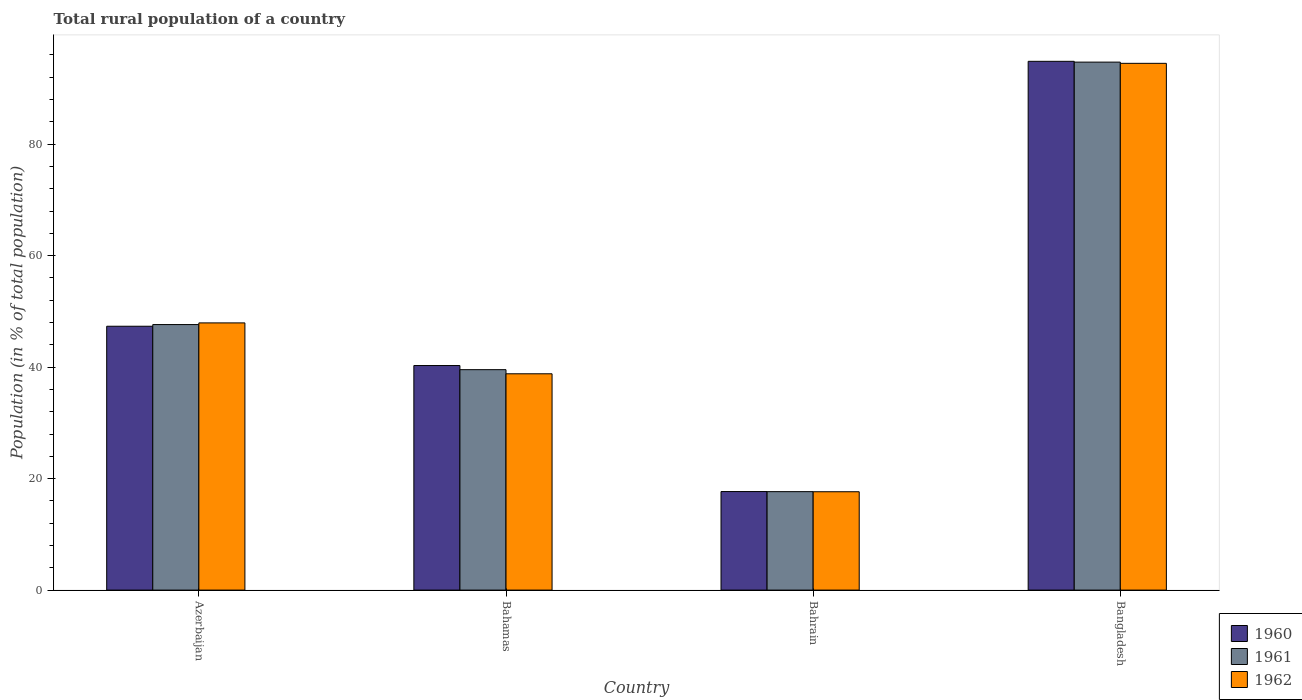How many groups of bars are there?
Offer a terse response. 4. What is the label of the 3rd group of bars from the left?
Your response must be concise. Bahrain. In how many cases, is the number of bars for a given country not equal to the number of legend labels?
Offer a terse response. 0. What is the rural population in 1962 in Bahrain?
Your response must be concise. 17.64. Across all countries, what is the maximum rural population in 1961?
Provide a short and direct response. 94.72. Across all countries, what is the minimum rural population in 1960?
Offer a very short reply. 17.68. In which country was the rural population in 1961 minimum?
Offer a very short reply. Bahrain. What is the total rural population in 1962 in the graph?
Provide a succinct answer. 198.89. What is the difference between the rural population in 1962 in Azerbaijan and that in Bahrain?
Your answer should be compact. 30.29. What is the difference between the rural population in 1962 in Azerbaijan and the rural population in 1960 in Bahamas?
Keep it short and to the point. 7.65. What is the average rural population in 1960 per country?
Your answer should be very brief. 50.04. What is the difference between the rural population of/in 1962 and rural population of/in 1960 in Bahamas?
Provide a succinct answer. -1.48. What is the ratio of the rural population in 1962 in Azerbaijan to that in Bangladesh?
Provide a short and direct response. 0.51. Is the rural population in 1962 in Azerbaijan less than that in Bangladesh?
Offer a very short reply. Yes. Is the difference between the rural population in 1962 in Bahamas and Bangladesh greater than the difference between the rural population in 1960 in Bahamas and Bangladesh?
Make the answer very short. No. What is the difference between the highest and the second highest rural population in 1960?
Your response must be concise. -54.58. What is the difference between the highest and the lowest rural population in 1961?
Your answer should be very brief. 77.06. Is the sum of the rural population in 1960 in Azerbaijan and Bahamas greater than the maximum rural population in 1961 across all countries?
Provide a short and direct response. No. How many bars are there?
Your answer should be very brief. 12. Are all the bars in the graph horizontal?
Offer a terse response. No. How many countries are there in the graph?
Provide a short and direct response. 4. What is the difference between two consecutive major ticks on the Y-axis?
Give a very brief answer. 20. Does the graph contain any zero values?
Keep it short and to the point. No. Does the graph contain grids?
Provide a short and direct response. No. How many legend labels are there?
Ensure brevity in your answer.  3. How are the legend labels stacked?
Give a very brief answer. Vertical. What is the title of the graph?
Provide a short and direct response. Total rural population of a country. Does "2013" appear as one of the legend labels in the graph?
Your answer should be compact. No. What is the label or title of the X-axis?
Ensure brevity in your answer.  Country. What is the label or title of the Y-axis?
Provide a short and direct response. Population (in % of total population). What is the Population (in % of total population) of 1960 in Azerbaijan?
Your answer should be compact. 47.34. What is the Population (in % of total population) in 1961 in Azerbaijan?
Keep it short and to the point. 47.64. What is the Population (in % of total population) in 1962 in Azerbaijan?
Your answer should be compact. 47.94. What is the Population (in % of total population) in 1960 in Bahamas?
Make the answer very short. 40.29. What is the Population (in % of total population) of 1961 in Bahamas?
Give a very brief answer. 39.55. What is the Population (in % of total population) of 1962 in Bahamas?
Provide a succinct answer. 38.81. What is the Population (in % of total population) in 1960 in Bahrain?
Keep it short and to the point. 17.68. What is the Population (in % of total population) in 1961 in Bahrain?
Give a very brief answer. 17.66. What is the Population (in % of total population) in 1962 in Bahrain?
Your answer should be very brief. 17.64. What is the Population (in % of total population) in 1960 in Bangladesh?
Make the answer very short. 94.86. What is the Population (in % of total population) of 1961 in Bangladesh?
Offer a terse response. 94.72. What is the Population (in % of total population) of 1962 in Bangladesh?
Offer a very short reply. 94.5. Across all countries, what is the maximum Population (in % of total population) of 1960?
Your answer should be very brief. 94.86. Across all countries, what is the maximum Population (in % of total population) in 1961?
Make the answer very short. 94.72. Across all countries, what is the maximum Population (in % of total population) in 1962?
Offer a very short reply. 94.5. Across all countries, what is the minimum Population (in % of total population) of 1960?
Make the answer very short. 17.68. Across all countries, what is the minimum Population (in % of total population) of 1961?
Ensure brevity in your answer.  17.66. Across all countries, what is the minimum Population (in % of total population) in 1962?
Give a very brief answer. 17.64. What is the total Population (in % of total population) in 1960 in the graph?
Provide a short and direct response. 200.17. What is the total Population (in % of total population) in 1961 in the graph?
Offer a terse response. 199.57. What is the total Population (in % of total population) of 1962 in the graph?
Provide a short and direct response. 198.89. What is the difference between the Population (in % of total population) in 1960 in Azerbaijan and that in Bahamas?
Keep it short and to the point. 7.05. What is the difference between the Population (in % of total population) in 1961 in Azerbaijan and that in Bahamas?
Make the answer very short. 8.09. What is the difference between the Population (in % of total population) in 1962 in Azerbaijan and that in Bahamas?
Your response must be concise. 9.13. What is the difference between the Population (in % of total population) of 1960 in Azerbaijan and that in Bahrain?
Keep it short and to the point. 29.66. What is the difference between the Population (in % of total population) in 1961 in Azerbaijan and that in Bahrain?
Your response must be concise. 29.97. What is the difference between the Population (in % of total population) in 1962 in Azerbaijan and that in Bahrain?
Your response must be concise. 30.29. What is the difference between the Population (in % of total population) of 1960 in Azerbaijan and that in Bangladesh?
Your response must be concise. -47.53. What is the difference between the Population (in % of total population) in 1961 in Azerbaijan and that in Bangladesh?
Give a very brief answer. -47.09. What is the difference between the Population (in % of total population) in 1962 in Azerbaijan and that in Bangladesh?
Your answer should be compact. -46.57. What is the difference between the Population (in % of total population) in 1960 in Bahamas and that in Bahrain?
Ensure brevity in your answer.  22.61. What is the difference between the Population (in % of total population) in 1961 in Bahamas and that in Bahrain?
Offer a very short reply. 21.88. What is the difference between the Population (in % of total population) of 1962 in Bahamas and that in Bahrain?
Your answer should be very brief. 21.16. What is the difference between the Population (in % of total population) in 1960 in Bahamas and that in Bangladesh?
Your answer should be very brief. -54.58. What is the difference between the Population (in % of total population) in 1961 in Bahamas and that in Bangladesh?
Your answer should be compact. -55.18. What is the difference between the Population (in % of total population) in 1962 in Bahamas and that in Bangladesh?
Provide a succinct answer. -55.7. What is the difference between the Population (in % of total population) in 1960 in Bahrain and that in Bangladesh?
Provide a succinct answer. -77.19. What is the difference between the Population (in % of total population) in 1961 in Bahrain and that in Bangladesh?
Provide a short and direct response. -77.06. What is the difference between the Population (in % of total population) of 1962 in Bahrain and that in Bangladesh?
Your response must be concise. -76.86. What is the difference between the Population (in % of total population) of 1960 in Azerbaijan and the Population (in % of total population) of 1961 in Bahamas?
Your response must be concise. 7.79. What is the difference between the Population (in % of total population) in 1960 in Azerbaijan and the Population (in % of total population) in 1962 in Bahamas?
Provide a succinct answer. 8.53. What is the difference between the Population (in % of total population) of 1961 in Azerbaijan and the Population (in % of total population) of 1962 in Bahamas?
Keep it short and to the point. 8.83. What is the difference between the Population (in % of total population) in 1960 in Azerbaijan and the Population (in % of total population) in 1961 in Bahrain?
Your answer should be very brief. 29.67. What is the difference between the Population (in % of total population) of 1960 in Azerbaijan and the Population (in % of total population) of 1962 in Bahrain?
Your answer should be compact. 29.69. What is the difference between the Population (in % of total population) in 1961 in Azerbaijan and the Population (in % of total population) in 1962 in Bahrain?
Your answer should be compact. 29.99. What is the difference between the Population (in % of total population) of 1960 in Azerbaijan and the Population (in % of total population) of 1961 in Bangladesh?
Your answer should be compact. -47.38. What is the difference between the Population (in % of total population) in 1960 in Azerbaijan and the Population (in % of total population) in 1962 in Bangladesh?
Your answer should be compact. -47.16. What is the difference between the Population (in % of total population) of 1961 in Azerbaijan and the Population (in % of total population) of 1962 in Bangladesh?
Offer a terse response. -46.87. What is the difference between the Population (in % of total population) in 1960 in Bahamas and the Population (in % of total population) in 1961 in Bahrain?
Provide a short and direct response. 22.62. What is the difference between the Population (in % of total population) in 1960 in Bahamas and the Population (in % of total population) in 1962 in Bahrain?
Your answer should be very brief. 22.64. What is the difference between the Population (in % of total population) of 1961 in Bahamas and the Population (in % of total population) of 1962 in Bahrain?
Provide a succinct answer. 21.9. What is the difference between the Population (in % of total population) in 1960 in Bahamas and the Population (in % of total population) in 1961 in Bangladesh?
Keep it short and to the point. -54.43. What is the difference between the Population (in % of total population) of 1960 in Bahamas and the Population (in % of total population) of 1962 in Bangladesh?
Offer a terse response. -54.21. What is the difference between the Population (in % of total population) in 1961 in Bahamas and the Population (in % of total population) in 1962 in Bangladesh?
Provide a succinct answer. -54.96. What is the difference between the Population (in % of total population) in 1960 in Bahrain and the Population (in % of total population) in 1961 in Bangladesh?
Give a very brief answer. -77.04. What is the difference between the Population (in % of total population) of 1960 in Bahrain and the Population (in % of total population) of 1962 in Bangladesh?
Your response must be concise. -76.82. What is the difference between the Population (in % of total population) of 1961 in Bahrain and the Population (in % of total population) of 1962 in Bangladesh?
Offer a terse response. -76.84. What is the average Population (in % of total population) of 1960 per country?
Keep it short and to the point. 50.04. What is the average Population (in % of total population) of 1961 per country?
Offer a terse response. 49.89. What is the average Population (in % of total population) in 1962 per country?
Your answer should be compact. 49.72. What is the difference between the Population (in % of total population) of 1960 and Population (in % of total population) of 1961 in Azerbaijan?
Ensure brevity in your answer.  -0.3. What is the difference between the Population (in % of total population) in 1960 and Population (in % of total population) in 1962 in Azerbaijan?
Provide a succinct answer. -0.6. What is the difference between the Population (in % of total population) of 1960 and Population (in % of total population) of 1961 in Bahamas?
Make the answer very short. 0.74. What is the difference between the Population (in % of total population) in 1960 and Population (in % of total population) in 1962 in Bahamas?
Keep it short and to the point. 1.48. What is the difference between the Population (in % of total population) in 1961 and Population (in % of total population) in 1962 in Bahamas?
Provide a short and direct response. 0.74. What is the difference between the Population (in % of total population) in 1960 and Population (in % of total population) in 1961 in Bahrain?
Offer a terse response. 0.02. What is the difference between the Population (in % of total population) of 1960 and Population (in % of total population) of 1962 in Bahrain?
Your response must be concise. 0.04. What is the difference between the Population (in % of total population) in 1961 and Population (in % of total population) in 1962 in Bahrain?
Your answer should be very brief. 0.02. What is the difference between the Population (in % of total population) of 1960 and Population (in % of total population) of 1961 in Bangladesh?
Offer a very short reply. 0.14. What is the difference between the Population (in % of total population) in 1960 and Population (in % of total population) in 1962 in Bangladesh?
Offer a terse response. 0.36. What is the difference between the Population (in % of total population) of 1961 and Population (in % of total population) of 1962 in Bangladesh?
Ensure brevity in your answer.  0.22. What is the ratio of the Population (in % of total population) in 1960 in Azerbaijan to that in Bahamas?
Your response must be concise. 1.18. What is the ratio of the Population (in % of total population) of 1961 in Azerbaijan to that in Bahamas?
Provide a succinct answer. 1.2. What is the ratio of the Population (in % of total population) in 1962 in Azerbaijan to that in Bahamas?
Your response must be concise. 1.24. What is the ratio of the Population (in % of total population) in 1960 in Azerbaijan to that in Bahrain?
Ensure brevity in your answer.  2.68. What is the ratio of the Population (in % of total population) in 1961 in Azerbaijan to that in Bahrain?
Offer a very short reply. 2.7. What is the ratio of the Population (in % of total population) in 1962 in Azerbaijan to that in Bahrain?
Offer a terse response. 2.72. What is the ratio of the Population (in % of total population) in 1960 in Azerbaijan to that in Bangladesh?
Ensure brevity in your answer.  0.5. What is the ratio of the Population (in % of total population) of 1961 in Azerbaijan to that in Bangladesh?
Keep it short and to the point. 0.5. What is the ratio of the Population (in % of total population) of 1962 in Azerbaijan to that in Bangladesh?
Your response must be concise. 0.51. What is the ratio of the Population (in % of total population) of 1960 in Bahamas to that in Bahrain?
Provide a short and direct response. 2.28. What is the ratio of the Population (in % of total population) of 1961 in Bahamas to that in Bahrain?
Provide a short and direct response. 2.24. What is the ratio of the Population (in % of total population) of 1962 in Bahamas to that in Bahrain?
Provide a succinct answer. 2.2. What is the ratio of the Population (in % of total population) of 1960 in Bahamas to that in Bangladesh?
Offer a terse response. 0.42. What is the ratio of the Population (in % of total population) in 1961 in Bahamas to that in Bangladesh?
Provide a short and direct response. 0.42. What is the ratio of the Population (in % of total population) of 1962 in Bahamas to that in Bangladesh?
Offer a terse response. 0.41. What is the ratio of the Population (in % of total population) of 1960 in Bahrain to that in Bangladesh?
Ensure brevity in your answer.  0.19. What is the ratio of the Population (in % of total population) in 1961 in Bahrain to that in Bangladesh?
Make the answer very short. 0.19. What is the ratio of the Population (in % of total population) of 1962 in Bahrain to that in Bangladesh?
Your answer should be compact. 0.19. What is the difference between the highest and the second highest Population (in % of total population) of 1960?
Keep it short and to the point. 47.53. What is the difference between the highest and the second highest Population (in % of total population) of 1961?
Provide a short and direct response. 47.09. What is the difference between the highest and the second highest Population (in % of total population) in 1962?
Provide a short and direct response. 46.57. What is the difference between the highest and the lowest Population (in % of total population) of 1960?
Your response must be concise. 77.19. What is the difference between the highest and the lowest Population (in % of total population) in 1961?
Offer a very short reply. 77.06. What is the difference between the highest and the lowest Population (in % of total population) of 1962?
Ensure brevity in your answer.  76.86. 